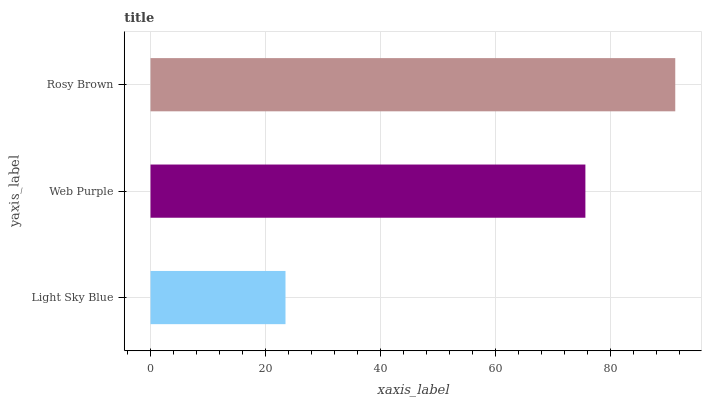Is Light Sky Blue the minimum?
Answer yes or no. Yes. Is Rosy Brown the maximum?
Answer yes or no. Yes. Is Web Purple the minimum?
Answer yes or no. No. Is Web Purple the maximum?
Answer yes or no. No. Is Web Purple greater than Light Sky Blue?
Answer yes or no. Yes. Is Light Sky Blue less than Web Purple?
Answer yes or no. Yes. Is Light Sky Blue greater than Web Purple?
Answer yes or no. No. Is Web Purple less than Light Sky Blue?
Answer yes or no. No. Is Web Purple the high median?
Answer yes or no. Yes. Is Web Purple the low median?
Answer yes or no. Yes. Is Rosy Brown the high median?
Answer yes or no. No. Is Rosy Brown the low median?
Answer yes or no. No. 